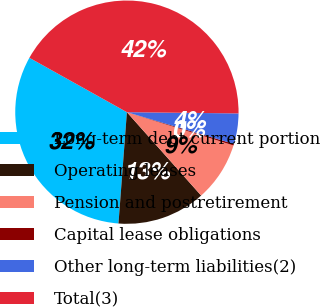Convert chart. <chart><loc_0><loc_0><loc_500><loc_500><pie_chart><fcel>Long-term debt current portion<fcel>Operating leases<fcel>Pension and postretirement<fcel>Capital lease obligations<fcel>Other long-term liabilities(2)<fcel>Total(3)<nl><fcel>31.89%<fcel>12.78%<fcel>8.6%<fcel>0.23%<fcel>4.41%<fcel>42.08%<nl></chart> 